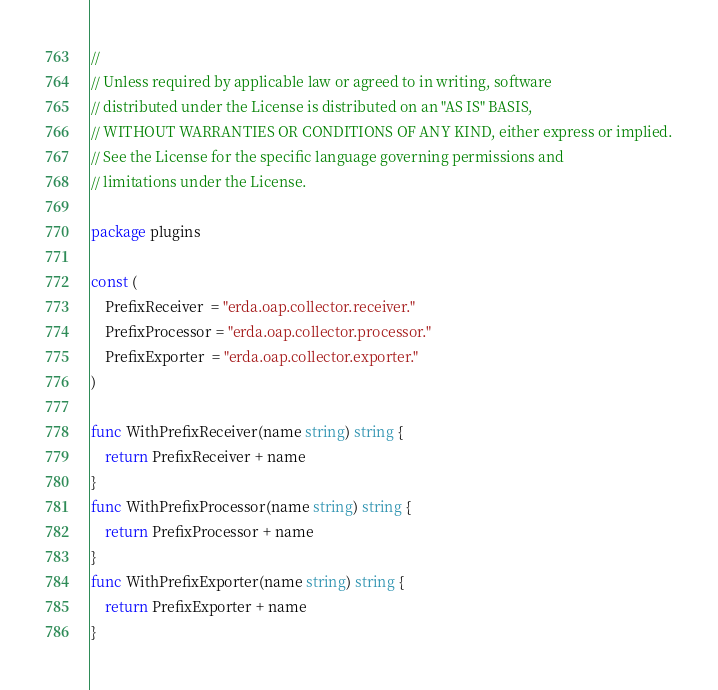<code> <loc_0><loc_0><loc_500><loc_500><_Go_>//
// Unless required by applicable law or agreed to in writing, software
// distributed under the License is distributed on an "AS IS" BASIS,
// WITHOUT WARRANTIES OR CONDITIONS OF ANY KIND, either express or implied.
// See the License for the specific language governing permissions and
// limitations under the License.

package plugins

const (
	PrefixReceiver  = "erda.oap.collector.receiver."
	PrefixProcessor = "erda.oap.collector.processor."
	PrefixExporter  = "erda.oap.collector.exporter."
)

func WithPrefixReceiver(name string) string {
	return PrefixReceiver + name
}
func WithPrefixProcessor(name string) string {
	return PrefixProcessor + name
}
func WithPrefixExporter(name string) string {
	return PrefixExporter + name
}
</code> 